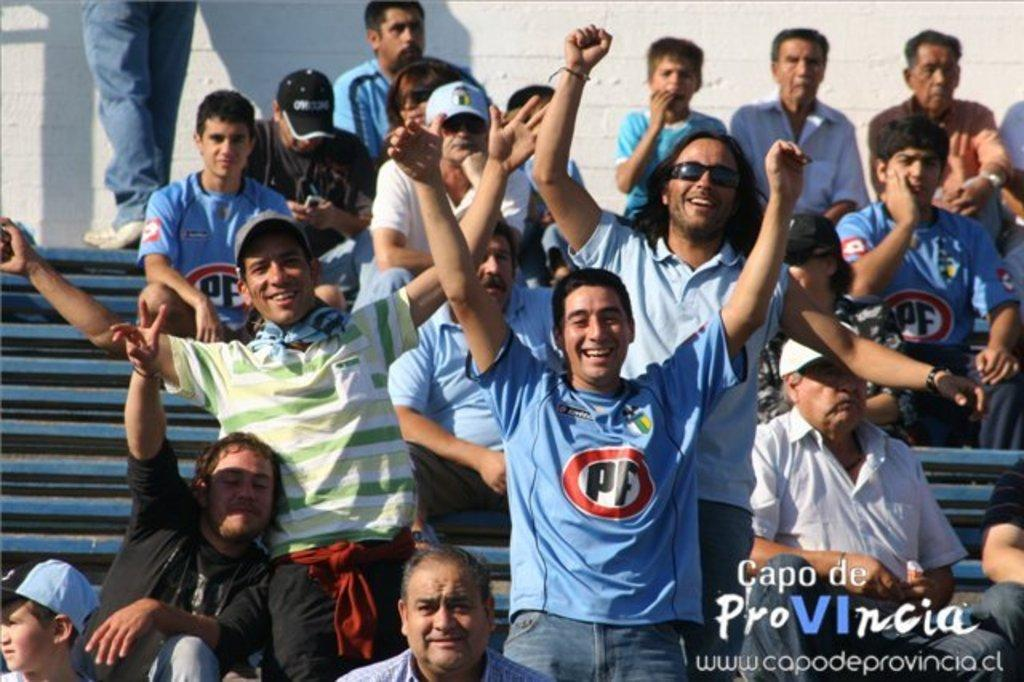What are the people in the image doing? There are people sitting on steps and standing in the image. What can be seen in the background of the image? There is a wall in the background of the image. Is there any text present in the image? Yes, there is text on the bottom right of the image. Can you tell me what the father is doing in the image? There is no father present in the image, as the facts provided do not mention any specific individuals or relationships. 